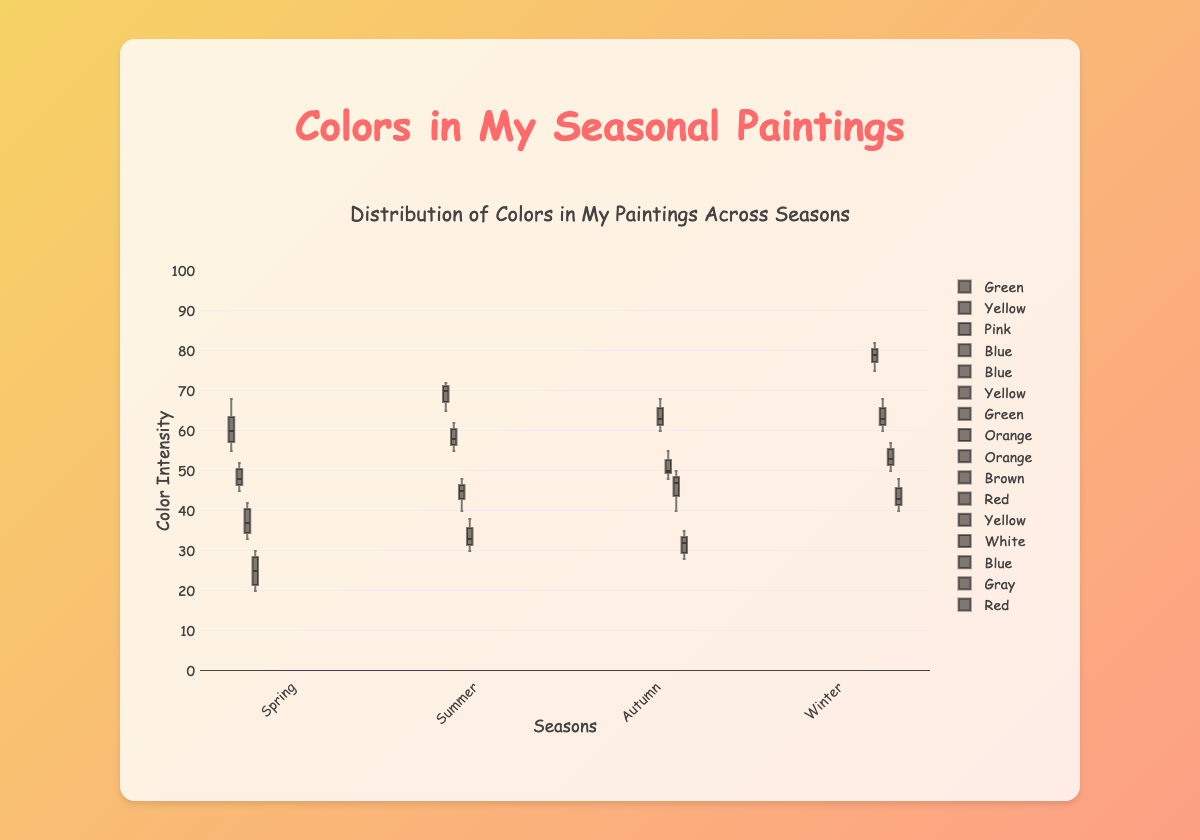What's the most used color in Winter? From the figure, we can observe that 'White' has the highest intensity range in Winter among all the colors, reaching up to 82 in some cases.
Answer: White Which season has the highest usage of 'Blue'? Checking the boxes labeled 'Blue' across different seasons shows that 'Blue' in Summer has the highest intensity range, reaching up to 72.
Answer: Summer What's the range of intensity for 'Yellow' in Spring? The range of 'Yellow' in Spring goes from its minimum (45) to its maximum (52). Thus, the range is 52 - 45 = 7.
Answer: 7 Comparing 'Orange' in Summer to 'Orange' in Autumn, which one has a higher median intensity? Looking at the box plots for 'Orange' in both seasons, the median line in Autumn is higher than that in Summer.
Answer: Autumn Which color is unique to Autumn? Inspecting the box plots for colors across seasons, we see that 'Brown' appears only in Autumn.
Answer: Brown What's the median intensity of 'Red' in Winter? Observing the box plot for 'Red' in Winter, the median line can be seen at 43.
Answer: 43 How does the distribution of 'Green' in Spring compare to that in Summer? 'Green' in Spring has a higher intensity range (55 to 68) compared to Summer (40 to 48). Spring's median is also higher.
Answer: Spring's 'Green' has a higher intensity and median Which season shows the highest variability in color intensity? By observing the spreads of the box plots, Winter clearly shows the highest variability, especially considering the spread in 'White'.
Answer: Winter Is 'Yellow' more evenly distributed in Spring or Autumn? The 'Yellow' box plot in Spring shows a more even and tight distribution compared to Autumn, where it is more spread out.
Answer: Spring 